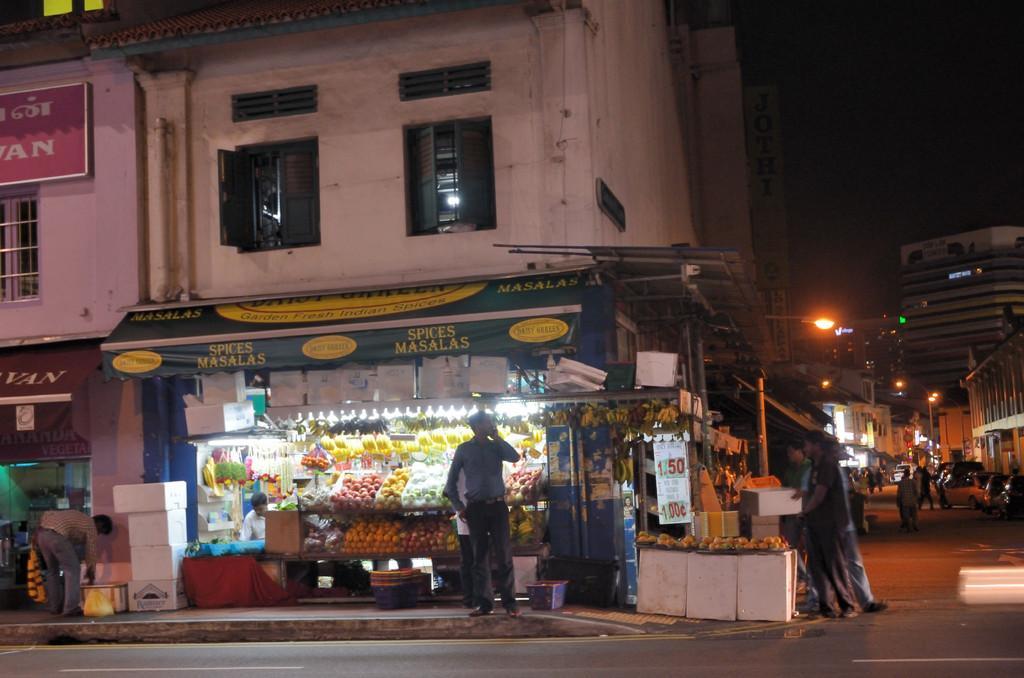Could you give a brief overview of what you see in this image? In this picture there is a man who is holding a mobile phone. He is standing near to the shop. In the fruit shop we can see an apples, bananas, grapes and other items. On the right we can see many cars and street lights on the road. On the left there is a building. At the top we can see the windows and board. In the bottom left there is a man who is standing near to the shop. In the top right there is a darkness. 